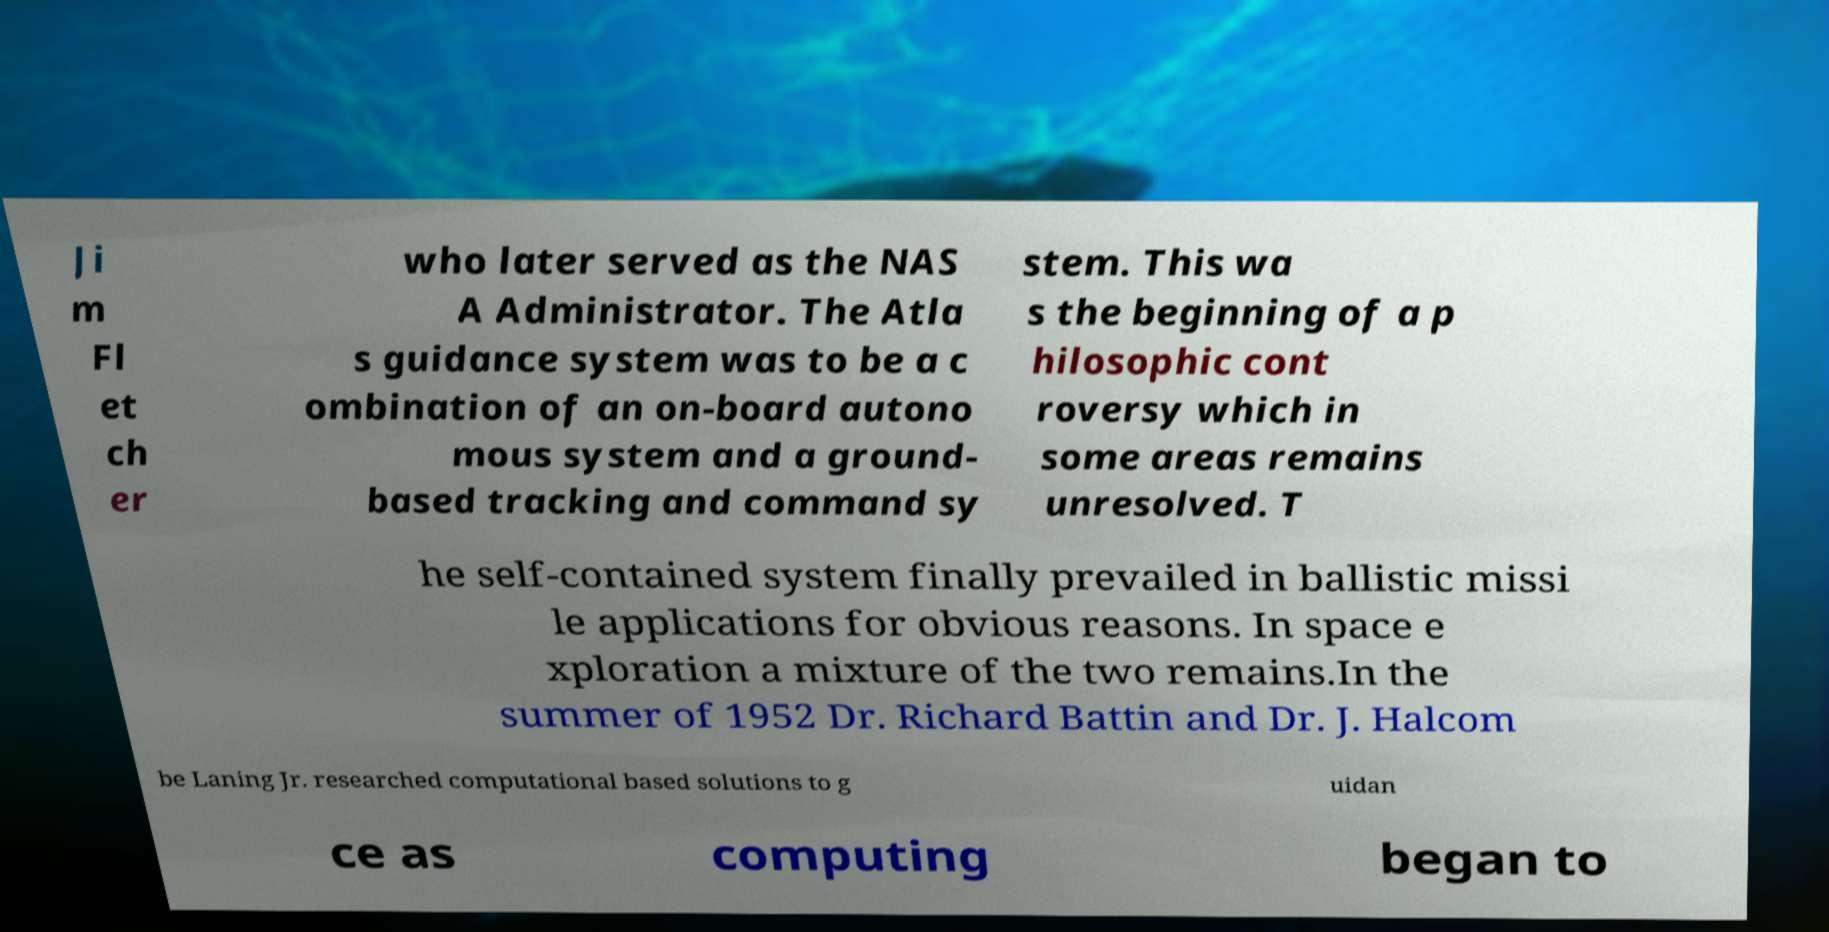I need the written content from this picture converted into text. Can you do that? Ji m Fl et ch er who later served as the NAS A Administrator. The Atla s guidance system was to be a c ombination of an on-board autono mous system and a ground- based tracking and command sy stem. This wa s the beginning of a p hilosophic cont roversy which in some areas remains unresolved. T he self-contained system finally prevailed in ballistic missi le applications for obvious reasons. In space e xploration a mixture of the two remains.In the summer of 1952 Dr. Richard Battin and Dr. J. Halcom be Laning Jr. researched computational based solutions to g uidan ce as computing began to 